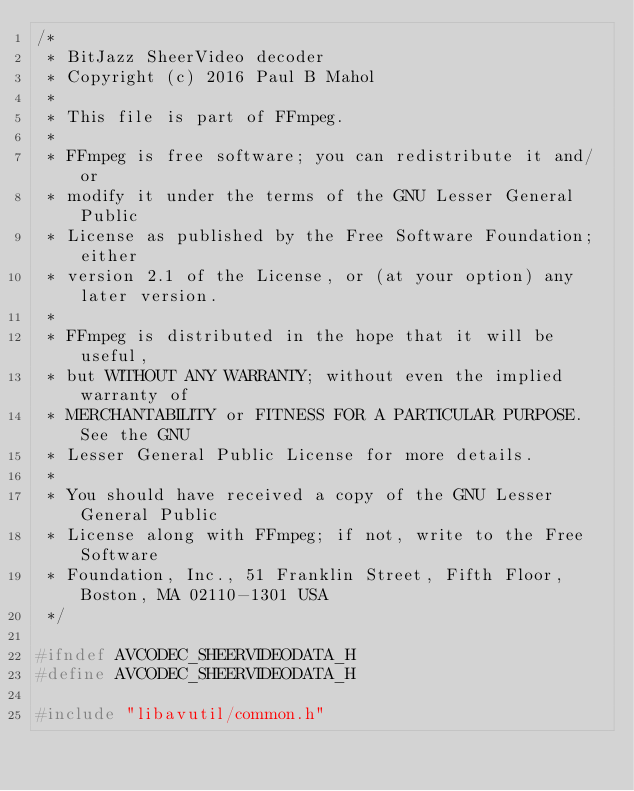Convert code to text. <code><loc_0><loc_0><loc_500><loc_500><_C_>/*
 * BitJazz SheerVideo decoder
 * Copyright (c) 2016 Paul B Mahol
 *
 * This file is part of FFmpeg.
 *
 * FFmpeg is free software; you can redistribute it and/or
 * modify it under the terms of the GNU Lesser General Public
 * License as published by the Free Software Foundation; either
 * version 2.1 of the License, or (at your option) any later version.
 *
 * FFmpeg is distributed in the hope that it will be useful,
 * but WITHOUT ANY WARRANTY; without even the implied warranty of
 * MERCHANTABILITY or FITNESS FOR A PARTICULAR PURPOSE.  See the GNU
 * Lesser General Public License for more details.
 *
 * You should have received a copy of the GNU Lesser General Public
 * License along with FFmpeg; if not, write to the Free Software
 * Foundation, Inc., 51 Franklin Street, Fifth Floor, Boston, MA 02110-1301 USA
 */

#ifndef AVCODEC_SHEERVIDEODATA_H
#define AVCODEC_SHEERVIDEODATA_H

#include "libavutil/common.h"
</code> 